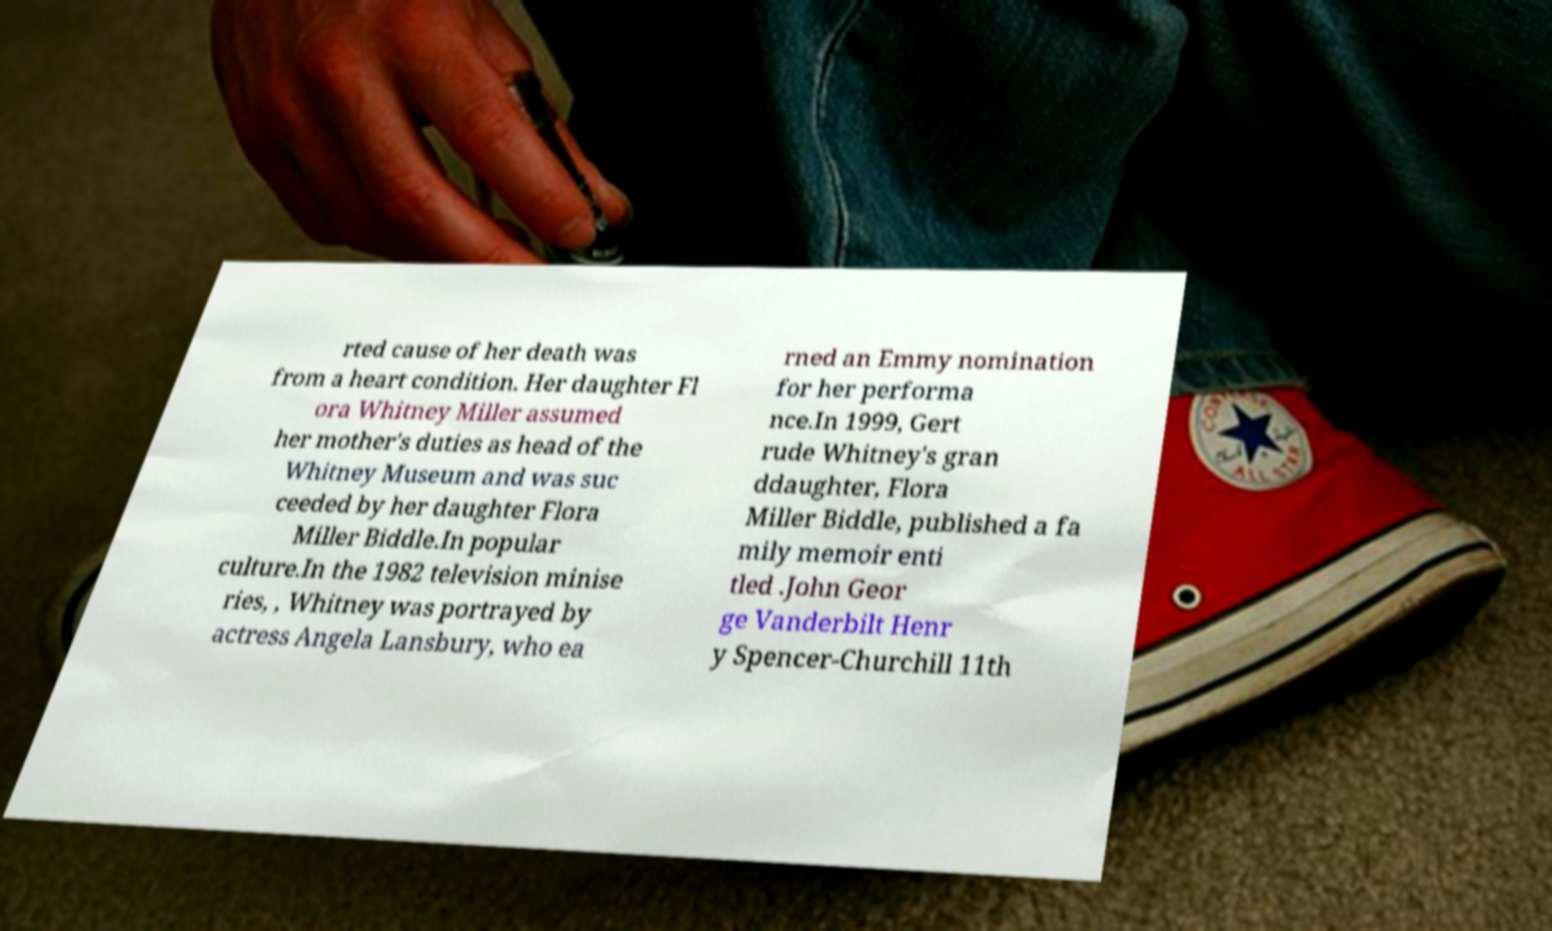For documentation purposes, I need the text within this image transcribed. Could you provide that? rted cause of her death was from a heart condition. Her daughter Fl ora Whitney Miller assumed her mother's duties as head of the Whitney Museum and was suc ceeded by her daughter Flora Miller Biddle.In popular culture.In the 1982 television minise ries, , Whitney was portrayed by actress Angela Lansbury, who ea rned an Emmy nomination for her performa nce.In 1999, Gert rude Whitney's gran ddaughter, Flora Miller Biddle, published a fa mily memoir enti tled .John Geor ge Vanderbilt Henr y Spencer-Churchill 11th 